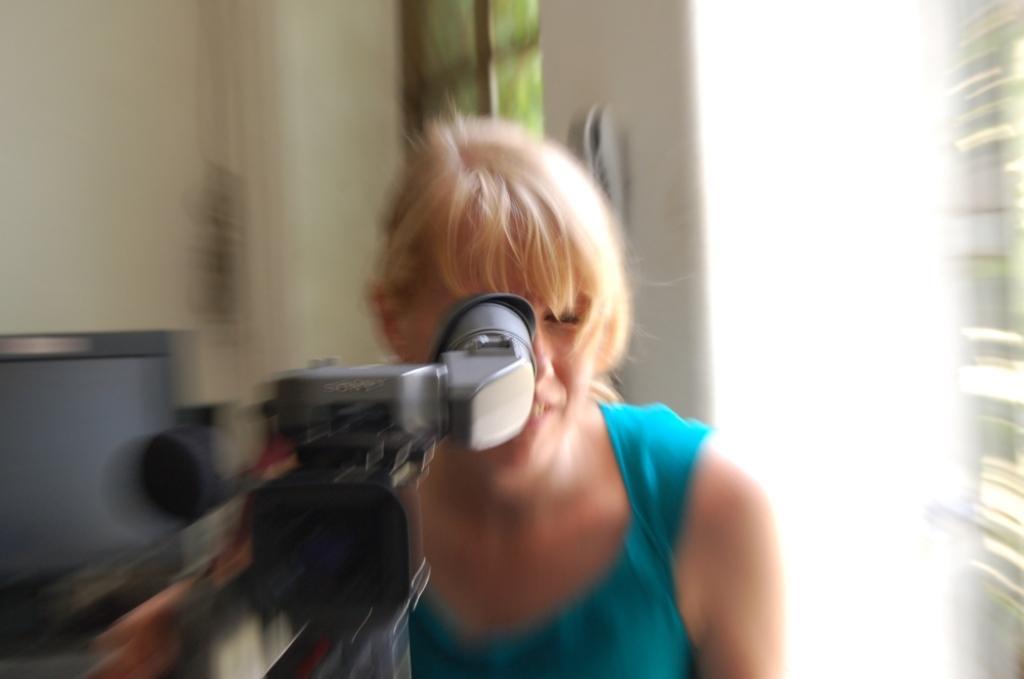Can you describe this image briefly? This is the picture of a room. In this image there is a woman standing behind the camera. At the back there is a computer on the table and there are windows and there is an object on the wall. 